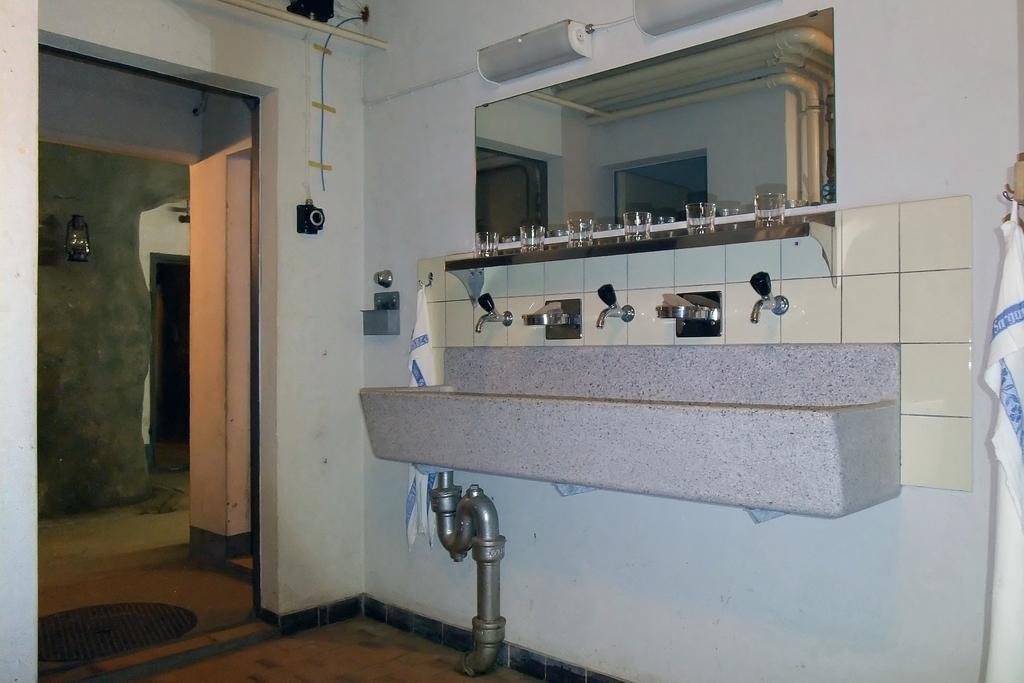What is the main object in the image? There is a washbasin in the image. What feature is present on the washbasin? There are taps on the washbasin. What is used for personal grooming in the image? There is a mirror in the image. What items are placed on the surface of the washbasin? There are glasses on the surface of the washbasin. What is located on the left side of the image? There is a doormat on the left side of the image. What provides illumination in the image? There is a light in the image. What type of pain can be seen on the face of the person in the image? There is no person present in the image, so it is not possible to determine if they are experiencing any pain. How many apples are visible in the image? There are no apples present in the image. 